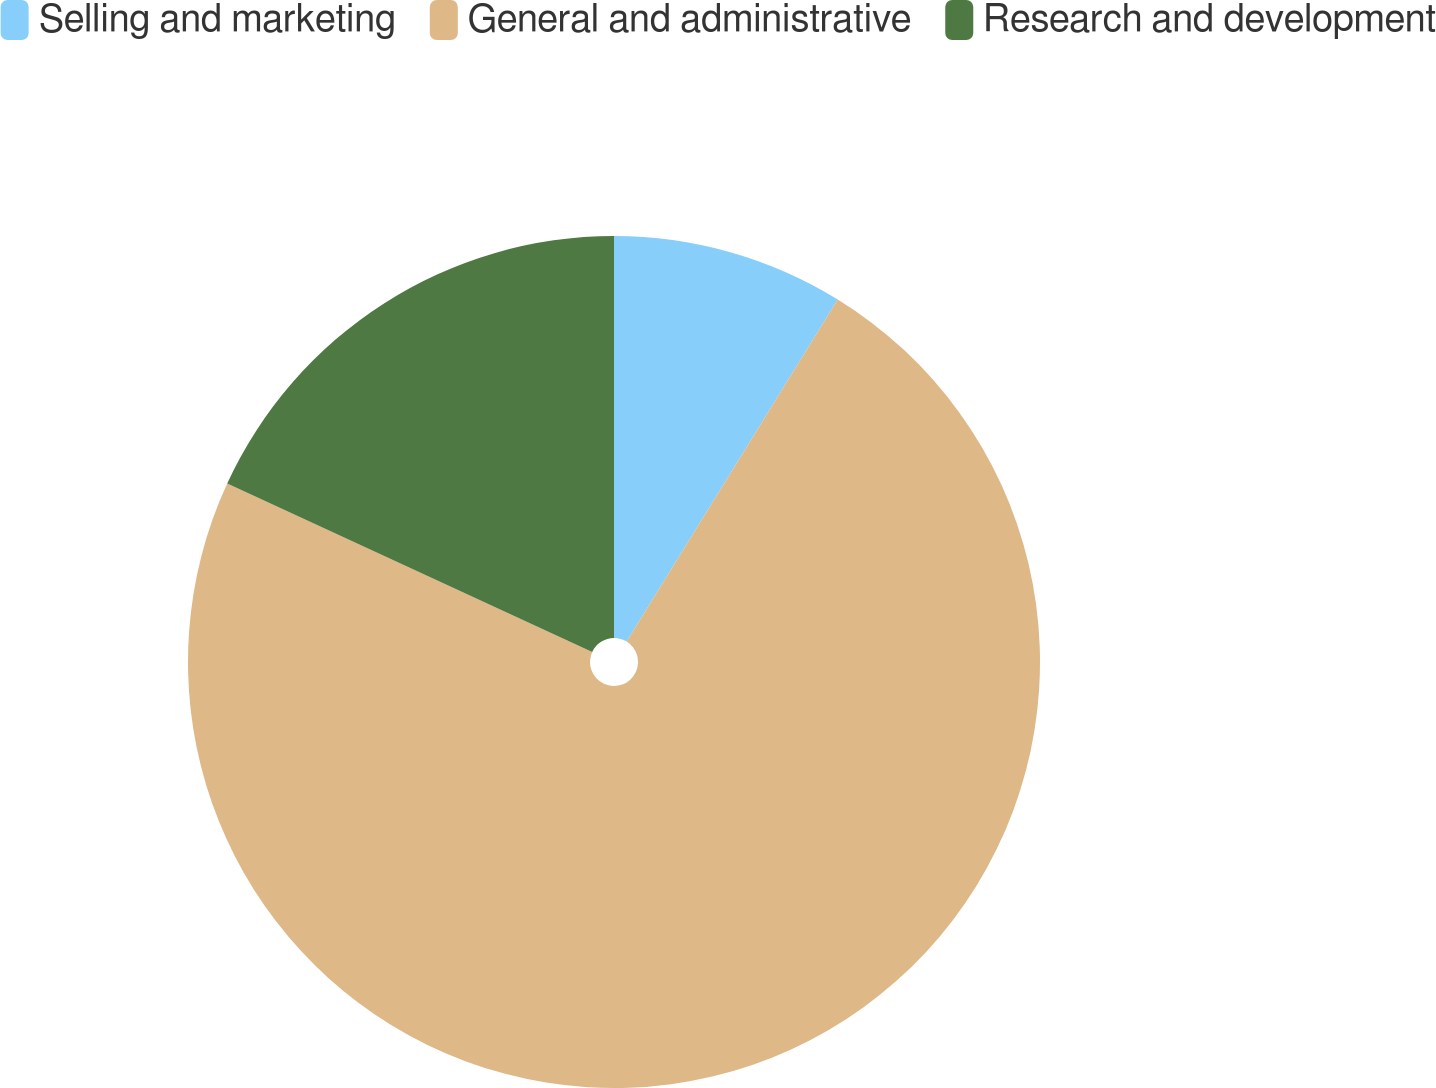Convert chart. <chart><loc_0><loc_0><loc_500><loc_500><pie_chart><fcel>Selling and marketing<fcel>General and administrative<fcel>Research and development<nl><fcel>8.8%<fcel>73.08%<fcel>18.12%<nl></chart> 